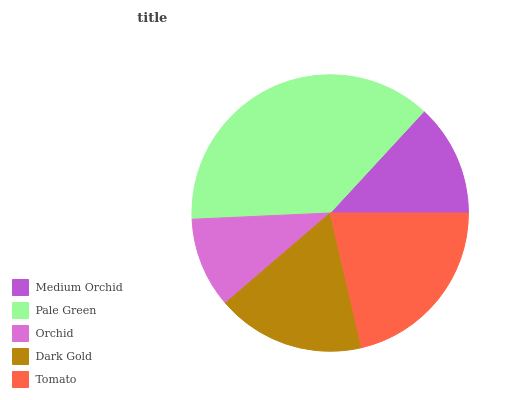Is Orchid the minimum?
Answer yes or no. Yes. Is Pale Green the maximum?
Answer yes or no. Yes. Is Pale Green the minimum?
Answer yes or no. No. Is Orchid the maximum?
Answer yes or no. No. Is Pale Green greater than Orchid?
Answer yes or no. Yes. Is Orchid less than Pale Green?
Answer yes or no. Yes. Is Orchid greater than Pale Green?
Answer yes or no. No. Is Pale Green less than Orchid?
Answer yes or no. No. Is Dark Gold the high median?
Answer yes or no. Yes. Is Dark Gold the low median?
Answer yes or no. Yes. Is Tomato the high median?
Answer yes or no. No. Is Orchid the low median?
Answer yes or no. No. 